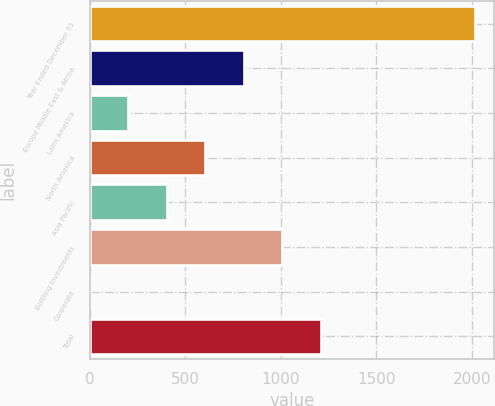<chart> <loc_0><loc_0><loc_500><loc_500><bar_chart><fcel>Year Ended December 31<fcel>Europe Middle East & Africa<fcel>Latin America<fcel>North America<fcel>Asia Pacific<fcel>Bottling Investments<fcel>Corporate<fcel>Total<nl><fcel>2016<fcel>806.58<fcel>201.87<fcel>605.01<fcel>403.44<fcel>1008.15<fcel>0.3<fcel>1209.72<nl></chart> 